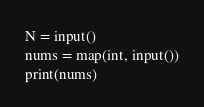Convert code to text. <code><loc_0><loc_0><loc_500><loc_500><_Python_>N = input()
nums = map(int, input())
print(nums)</code> 